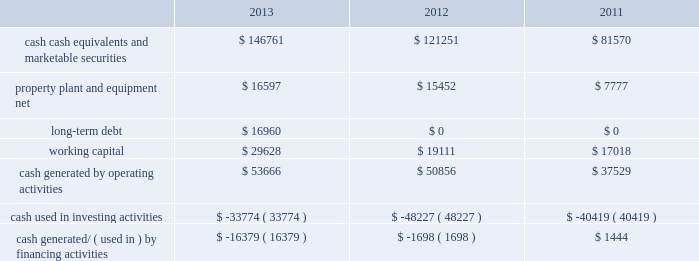Table of contents adjustments that may result from tax examinations .
However , the outcome of tax audits cannot be predicted with certainty .
If any issues addressed in the company 2019s tax audits are resolved in a manner not consistent with management 2019s expectations , the company could be required to adjust its provision for income taxes in the period such resolution occurs .
Liquidity and capital resources the table presents selected financial information and statistics as of and for the years ended september 28 , 2013 , september 29 , 2012 and september 24 , 2011 ( in millions ) : the company believes its existing balances of cash , cash equivalents and marketable securities will be sufficient to satisfy its working capital needs , capital asset purchases , outstanding commitments , and other liquidity requirements associated with its existing operations over the next 12 months .
The company anticipates the cash used for future dividends and the share repurchase program will come from its current domestic cash , cash generated from on-going u.s .
Operating activities and from borrowings .
As of september 28 , 2013 and september 29 , 2012 , $ 111.3 billion and $ 82.6 billion , respectively , of the company 2019s cash , cash equivalents and marketable securities were held by foreign subsidiaries and are generally based in u.s .
Dollar-denominated holdings .
Amounts held by foreign subsidiaries are generally subject to u.s .
Income taxation on repatriation to the u.s .
The company 2019s marketable securities investment portfolio is invested primarily in highly-rated securities and its investment policy generally limits the amount of credit exposure to any one issuer .
The policy requires investments generally to be investment grade with the objective of minimizing the potential risk of principal loss .
During 2013 , cash generated from operating activities of $ 53.7 billion was a result of $ 37.0 billion of net income , non-cash adjustments to net income of $ 10.2 billion and an increase in net change in operating assets and liabilities of $ 6.5 billion .
Cash used in investing activities of $ 33.8 billion during 2013 consisted primarily of net purchases , sales and maturities of marketable securities of $ 24.0 billion and cash used to acquire property , plant and equipment of $ 8.2 billion .
Cash used in financing activities during 2013 consisted primarily of cash used to repurchase common stock of $ 22.9 billion and cash used to pay dividends and dividend equivalent rights of $ 10.6 billion , partially offset by net proceeds from the issuance of long-term debt of $ 16.9 billion .
During 2012 , cash generated from operating activities of $ 50.9 billion was a result of $ 41.7 billion of net income and non-cash adjustments to net income of $ 9.4 billion , partially offset by a decrease in net operating assets and liabilities of $ 299 million .
Cash used in investing activities during 2012 of $ 48.2 billion consisted primarily of net purchases , sales and maturities of marketable securities of $ 38.4 billion and cash used to acquire property , plant and equipment of $ 8.3 billion .
Cash used in financing activities during 2012 of $ 1.7 billion consisted primarily of cash used to pay dividends and dividend equivalent rights of $ 2.5 billion .
Capital assets the company 2019s capital expenditures were $ 7.0 billion during 2013 , consisting of $ 499 million for retail store facilities and $ 6.5 billion for other capital expenditures , including product tooling and manufacturing process equipment , and other corporate facilities and infrastructure .
The company 2019s actual cash payments for capital expenditures during 2013 were $ 8.2 billion. .

Cash used in investing activities during 2012 was $ 48.2 billion . what percentage of this consisted of cash used to acquire property , plant and equipment? 
Computations: (8.3 / 48.2)
Answer: 0.1722. 